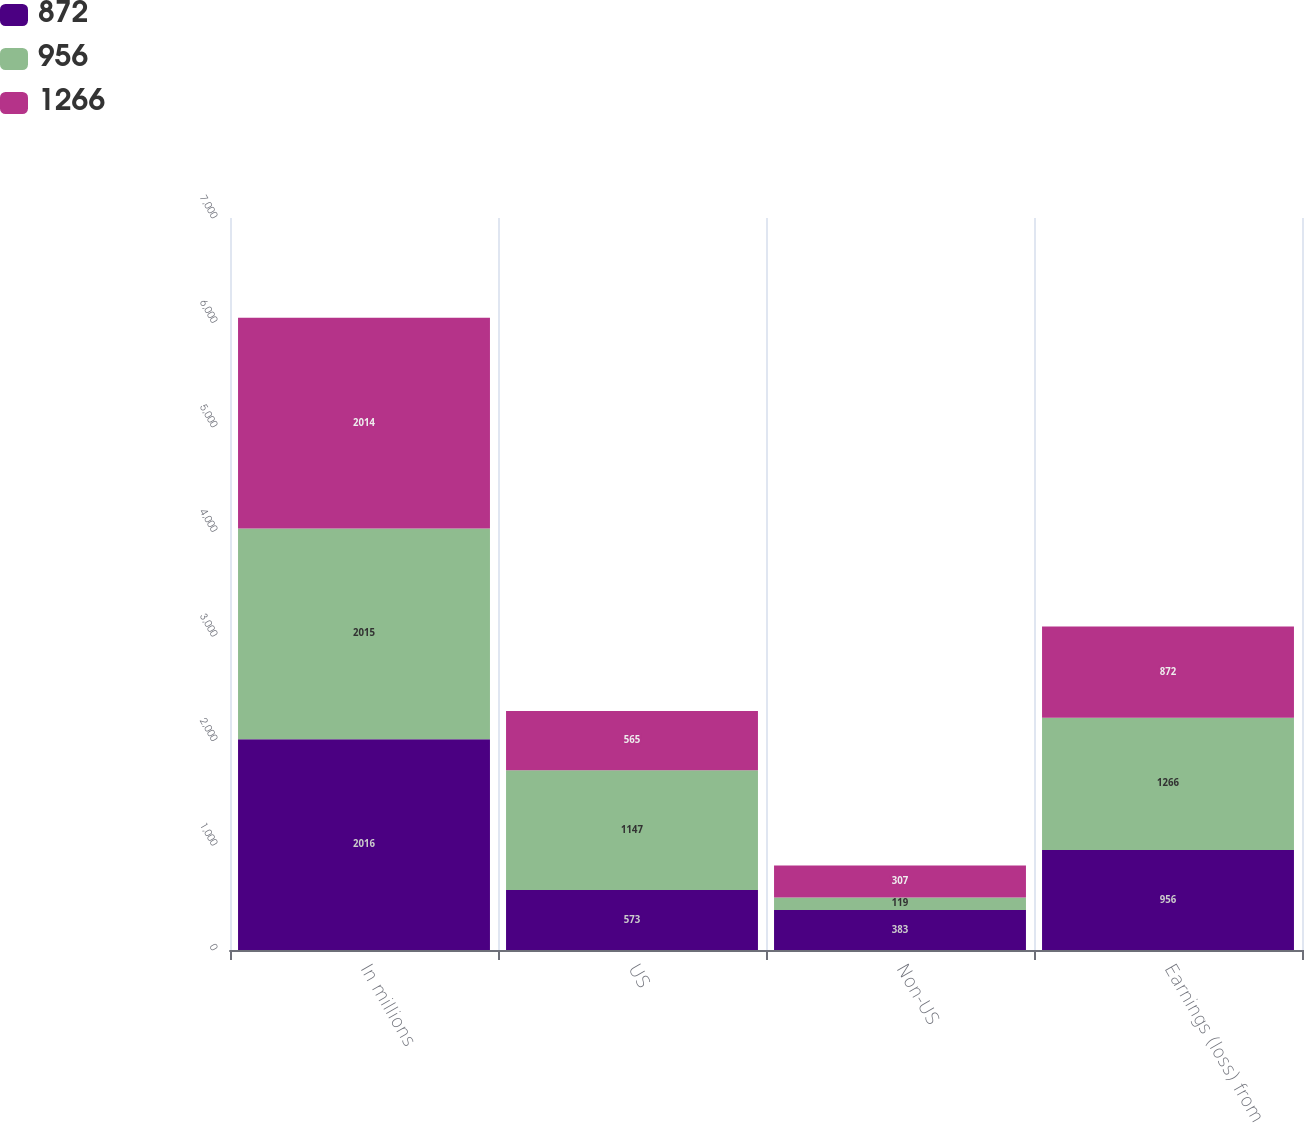<chart> <loc_0><loc_0><loc_500><loc_500><stacked_bar_chart><ecel><fcel>In millions<fcel>US<fcel>Non-US<fcel>Earnings (loss) from<nl><fcel>872<fcel>2016<fcel>573<fcel>383<fcel>956<nl><fcel>956<fcel>2015<fcel>1147<fcel>119<fcel>1266<nl><fcel>1266<fcel>2014<fcel>565<fcel>307<fcel>872<nl></chart> 